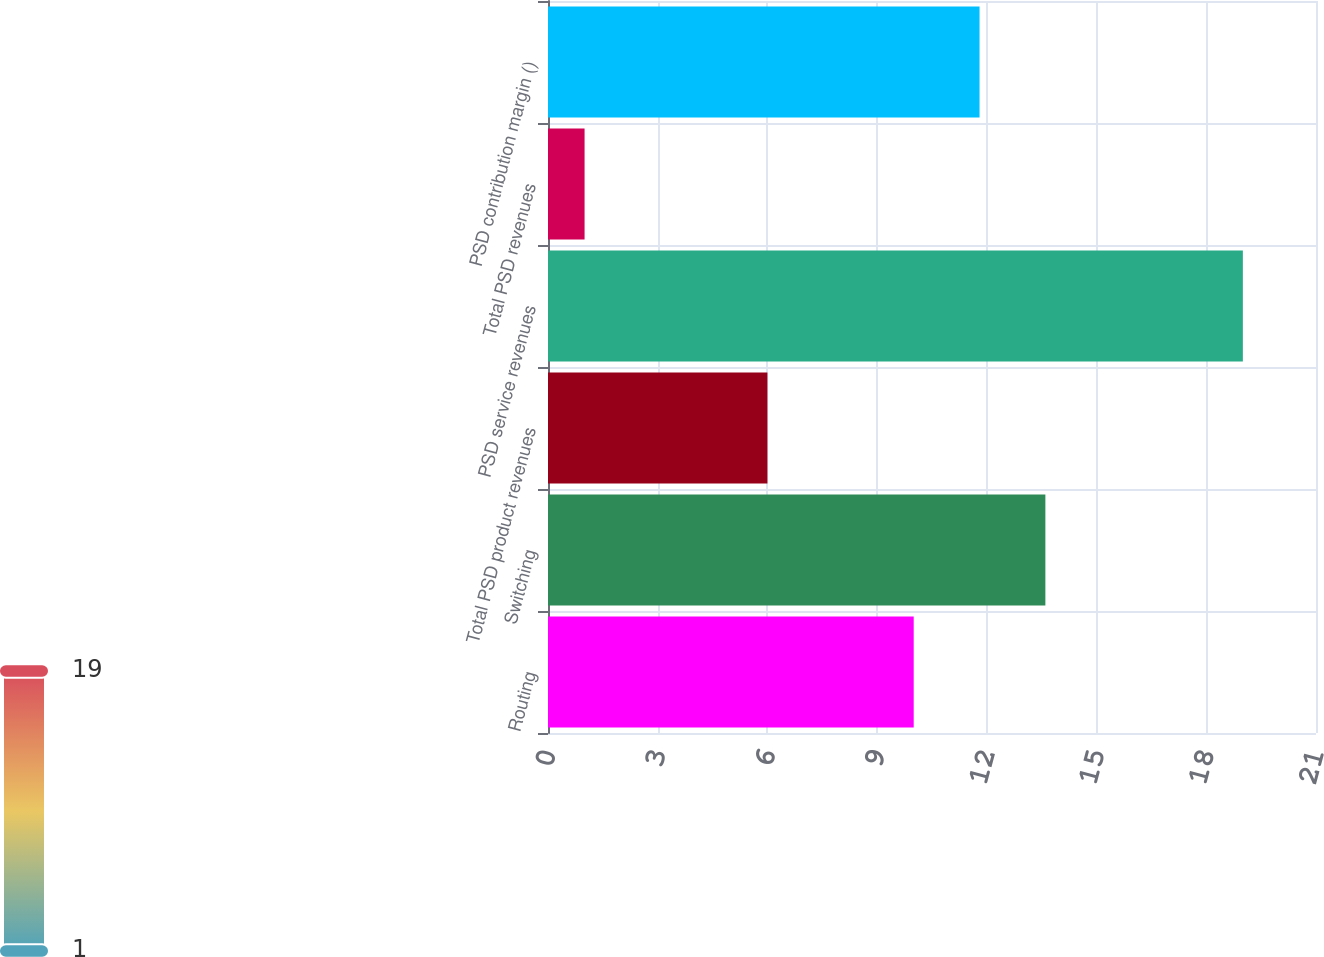Convert chart to OTSL. <chart><loc_0><loc_0><loc_500><loc_500><bar_chart><fcel>Routing<fcel>Switching<fcel>Total PSD product revenues<fcel>PSD service revenues<fcel>Total PSD revenues<fcel>PSD contribution margin ()<nl><fcel>10<fcel>13.6<fcel>6<fcel>19<fcel>1<fcel>11.8<nl></chart> 